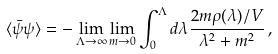<formula> <loc_0><loc_0><loc_500><loc_500>\langle \bar { \psi } \psi \rangle = - \lim _ { \Lambda \to \infty } \lim _ { m \to 0 } \int _ { 0 } ^ { \Lambda } d \lambda \frac { 2 m \rho ( \lambda ) / V } { \lambda ^ { 2 } + m ^ { 2 } } \, ,</formula> 